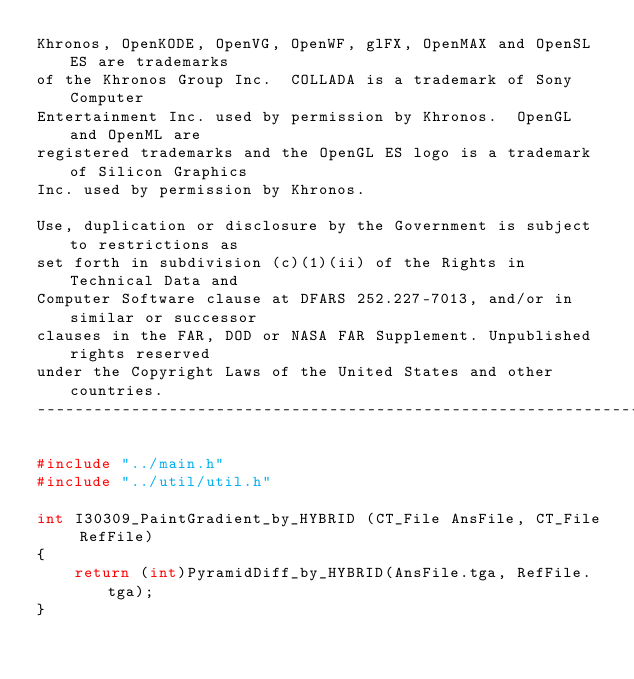Convert code to text. <code><loc_0><loc_0><loc_500><loc_500><_C_>Khronos, OpenKODE, OpenVG, OpenWF, glFX, OpenMAX and OpenSL ES are trademarks
of the Khronos Group Inc.  COLLADA is a trademark of Sony Computer
Entertainment Inc. used by permission by Khronos.  OpenGL and OpenML are
registered trademarks and the OpenGL ES logo is a trademark of Silicon Graphics
Inc. used by permission by Khronos. 

Use, duplication or disclosure by the Government is subject to restrictions as
set forth in subdivision (c)(1)(ii) of the Rights in Technical Data and
Computer Software clause at DFARS 252.227-7013, and/or in similar or successor
clauses in the FAR, DOD or NASA FAR Supplement. Unpublished rights reserved
under the Copyright Laws of the United States and other countries.
------------------------------------------------------------------------------*/

#include "../main.h"
#include "../util/util.h"

int I30309_PaintGradient_by_HYBRID (CT_File AnsFile, CT_File RefFile)
{
    return (int)PyramidDiff_by_HYBRID(AnsFile.tga, RefFile.tga);
}
</code> 